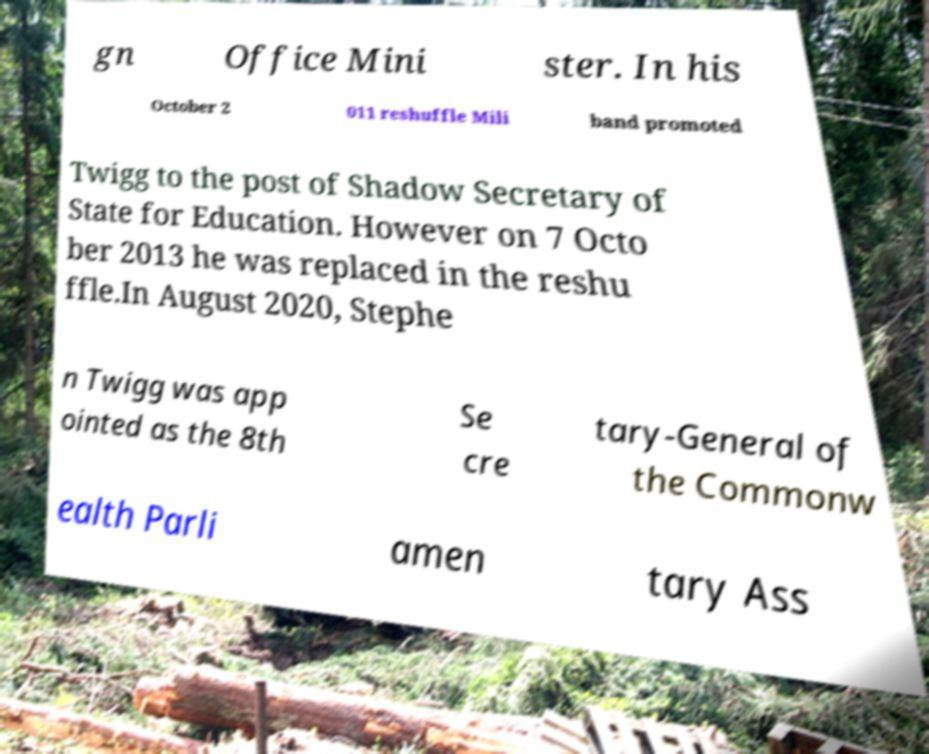Could you extract and type out the text from this image? gn Office Mini ster. In his October 2 011 reshuffle Mili band promoted Twigg to the post of Shadow Secretary of State for Education. However on 7 Octo ber 2013 he was replaced in the reshu ffle.In August 2020, Stephe n Twigg was app ointed as the 8th Se cre tary-General of the Commonw ealth Parli amen tary Ass 